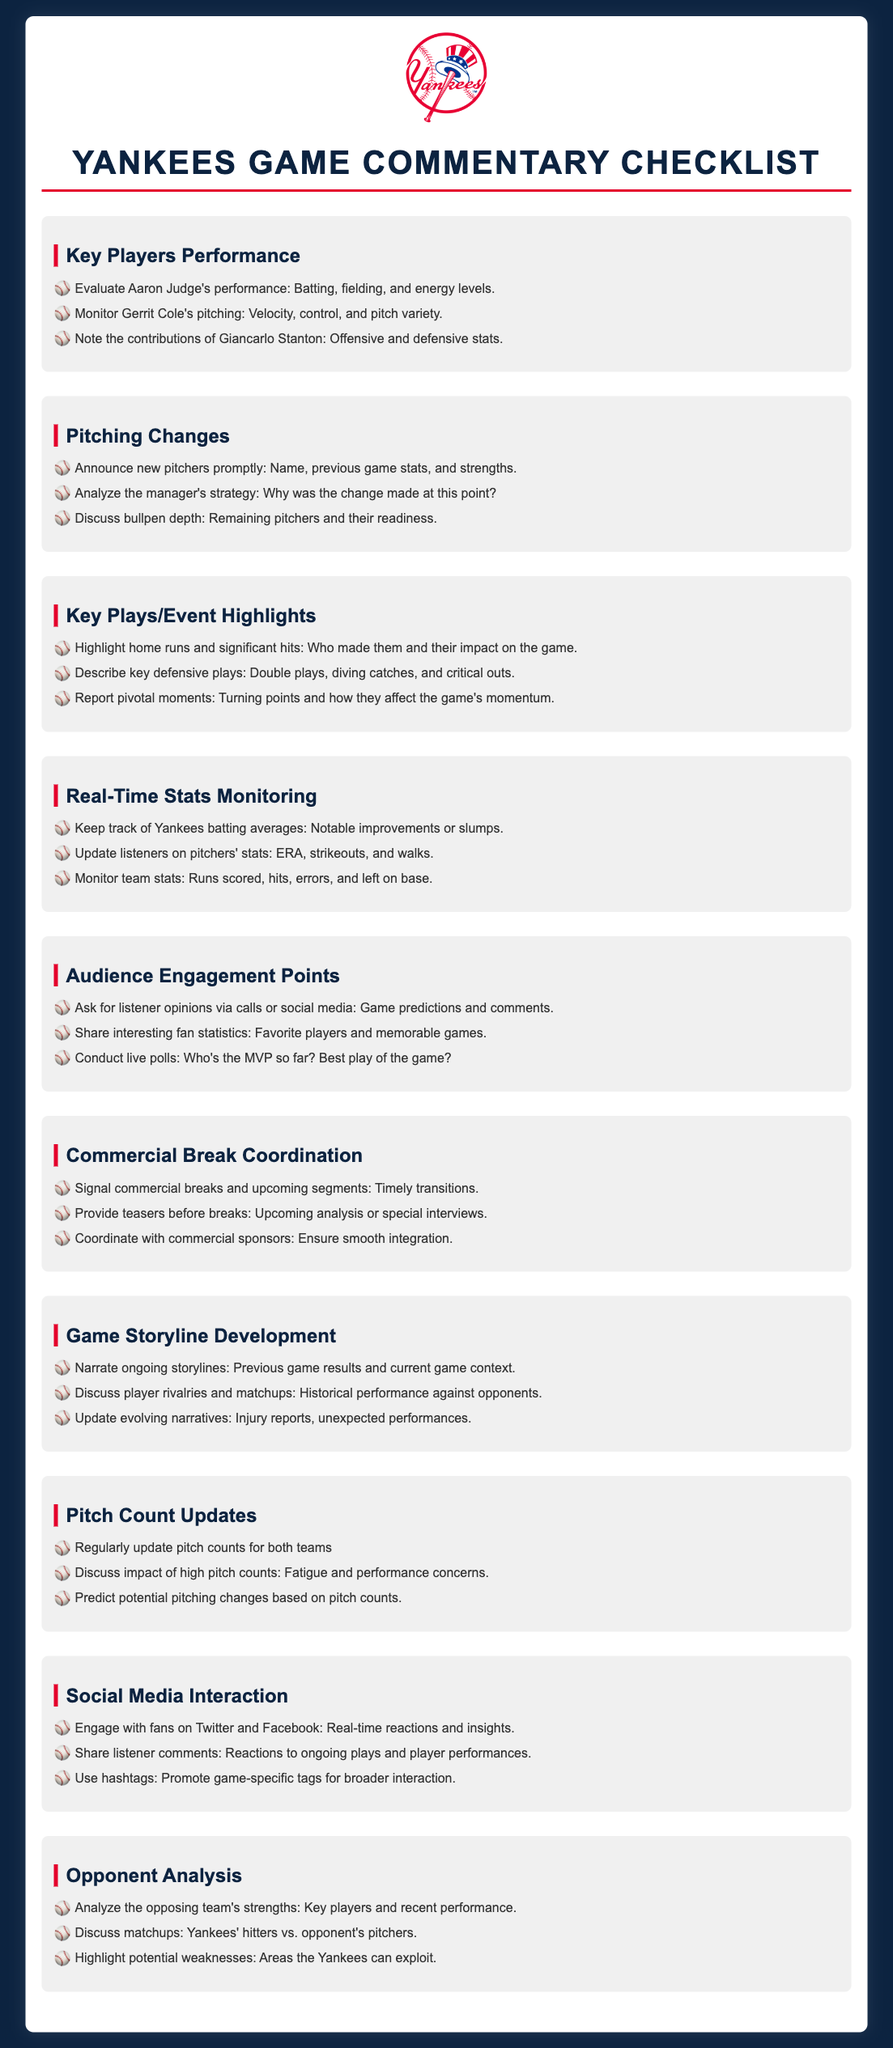What is the title of the document? The title of the document is displayed prominently at the top of the content.
Answer: Yankees Game Commentary Checklist Who is a key player mentioned under "Key Players Performance"? "Key Players Performance" highlights specific individuals who are critical in the game.
Answer: Aaron Judge What should be analyzed regarding pitching changes? This section discusses several aspects of pitching changes, including strategies and readiness of pitchers.
Answer: Manager's strategy How many key plays/events should be highlighted? The document indicates three key areas to highlight plays/events during the game.
Answer: Three What is an audience engagement tactic mentioned? This section provides methods to actively involve the audience during commentary.
Answer: Live polls What is one thing to monitor in "Real-Time Stats Monitoring"? The document outlines specific statistics to track during the game related to player performance.
Answer: Pitchers' stats What is a focus area in "Opponent Analysis"? This section emphasizes evaluations specific to the opposing team's capabilities.
Answer: Strengths How often should pitch counts be updated? The checklist suggests a regular update on pitch counts for both teams during the game.
Answer: Regularly What color does the header use for key sections? Each section header is given a consistent color to enhance visibility and organization.
Answer: Dark blue 